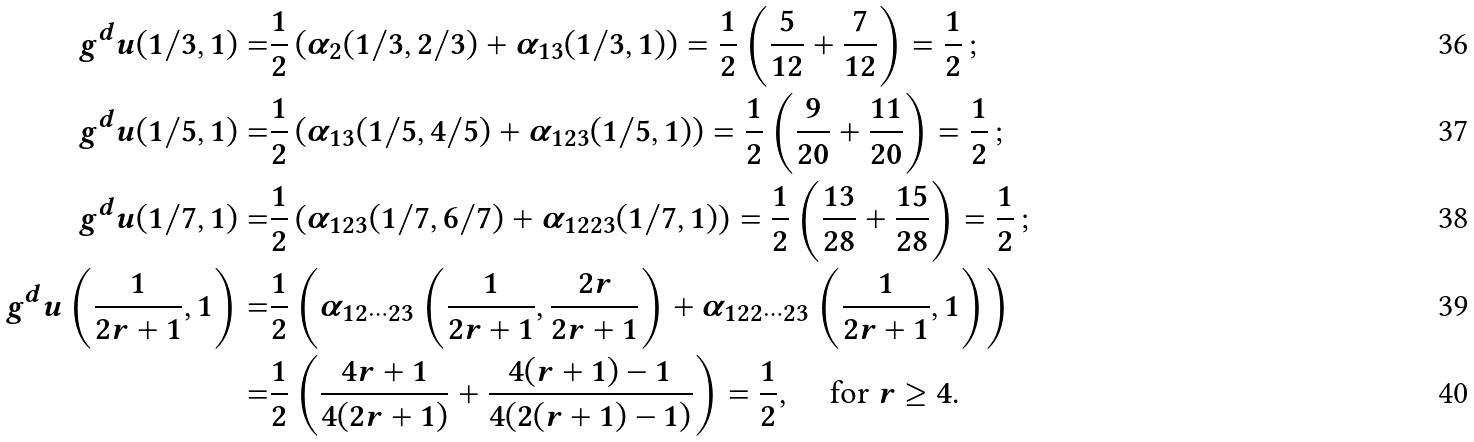<formula> <loc_0><loc_0><loc_500><loc_500>g ^ { d } u ( 1 / 3 , 1 ) = & \frac { 1 } { 2 } \left ( \alpha _ { 2 } ( 1 / 3 , 2 / 3 ) + \alpha _ { 1 3 } ( 1 / 3 , 1 ) \right ) = \frac { 1 } { 2 } \left ( \frac { 5 } { 1 2 } + \frac { 7 } { 1 2 } \right ) = \frac { 1 } { 2 } \, ; \\ g ^ { d } u ( 1 / 5 , 1 ) = & \frac { 1 } { 2 } \left ( \alpha _ { 1 3 } ( 1 / 5 , 4 / 5 ) + \alpha _ { 1 2 3 } ( 1 / 5 , 1 ) \right ) = \frac { 1 } { 2 } \left ( \frac { 9 } { 2 0 } + \frac { 1 1 } { 2 0 } \right ) = \frac { 1 } { 2 } \, ; \\ g ^ { d } u ( 1 / 7 , 1 ) = & \frac { 1 } { 2 } \left ( \alpha _ { 1 2 3 } ( 1 / 7 , 6 / 7 ) + \alpha _ { 1 2 2 3 } ( 1 / 7 , 1 ) \right ) = \frac { 1 } { 2 } \left ( \frac { 1 3 } { 2 8 } + \frac { 1 5 } { 2 8 } \right ) = \frac { 1 } { 2 } \, ; \\ g ^ { d } u \left ( \frac { 1 } { 2 r + 1 } , 1 \right ) = & \frac { 1 } { 2 } \left ( \alpha _ { 1 2 \cdots 2 3 } \left ( \frac { 1 } { 2 r + 1 } , \frac { 2 r } { 2 r + 1 } \right ) + \alpha _ { 1 2 2 \cdots 2 3 } \left ( \frac { 1 } { 2 r + 1 } , 1 \right ) \right ) \\ = & \frac { 1 } { 2 } \left ( \frac { 4 r + 1 } { 4 ( 2 r + 1 ) } + \frac { 4 ( r + 1 ) - 1 } { 4 ( 2 ( r + 1 ) - 1 ) } \right ) = \frac { 1 } { 2 } , \, \quad \text {for $r\geq 4$} .</formula> 